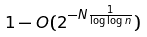Convert formula to latex. <formula><loc_0><loc_0><loc_500><loc_500>1 - O ( 2 ^ { - N \frac { 1 } { \log \log n } } )</formula> 